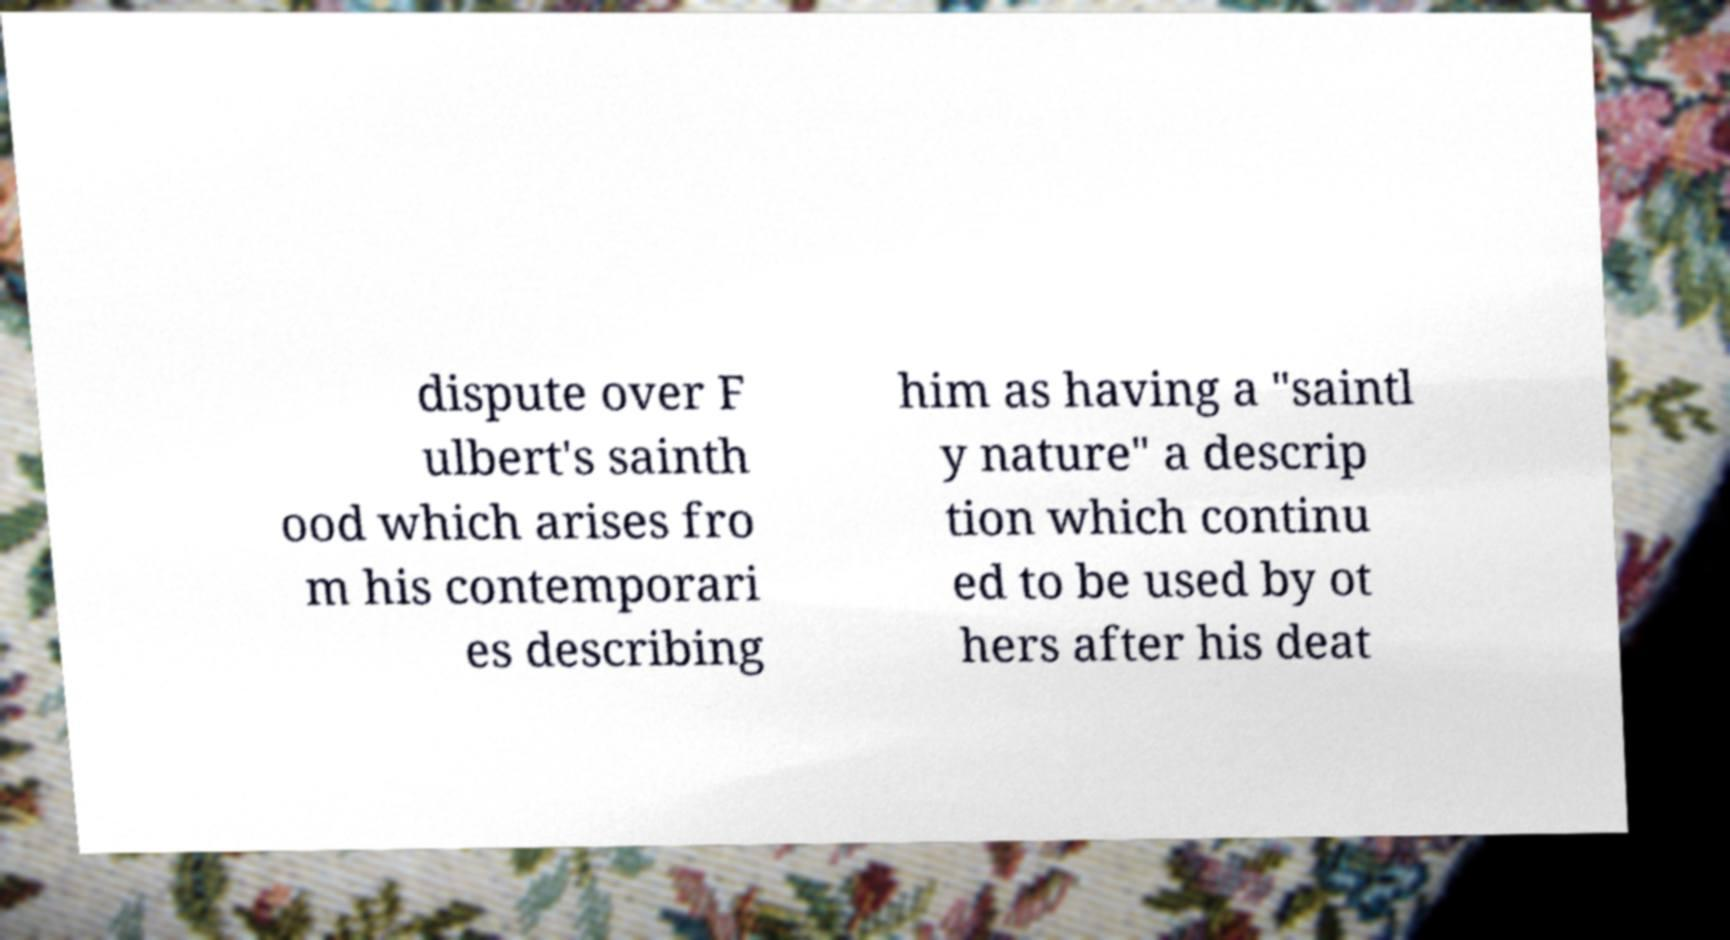Can you accurately transcribe the text from the provided image for me? dispute over F ulbert's sainth ood which arises fro m his contemporari es describing him as having a "saintl y nature" a descrip tion which continu ed to be used by ot hers after his deat 